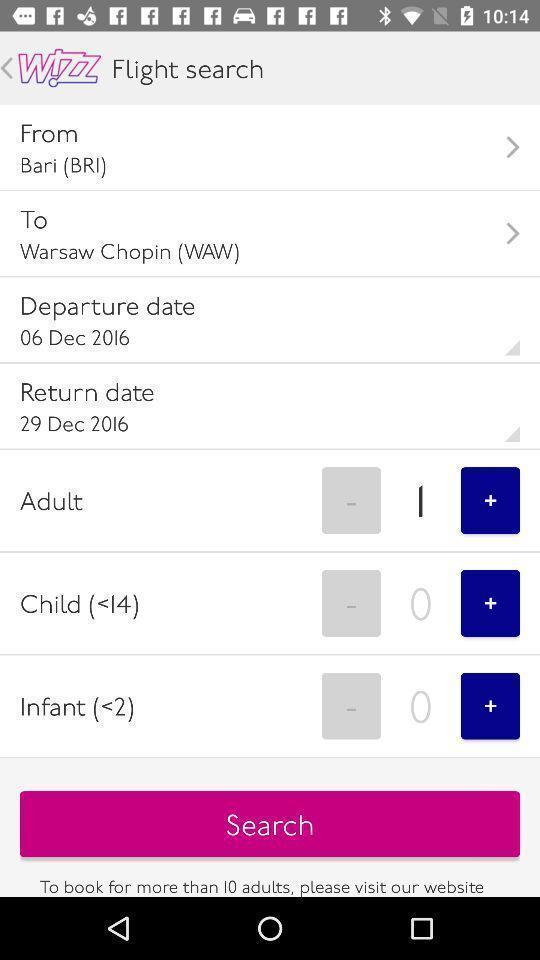Tell me about the visual elements in this screen capture. Search page for a flight booking application. 